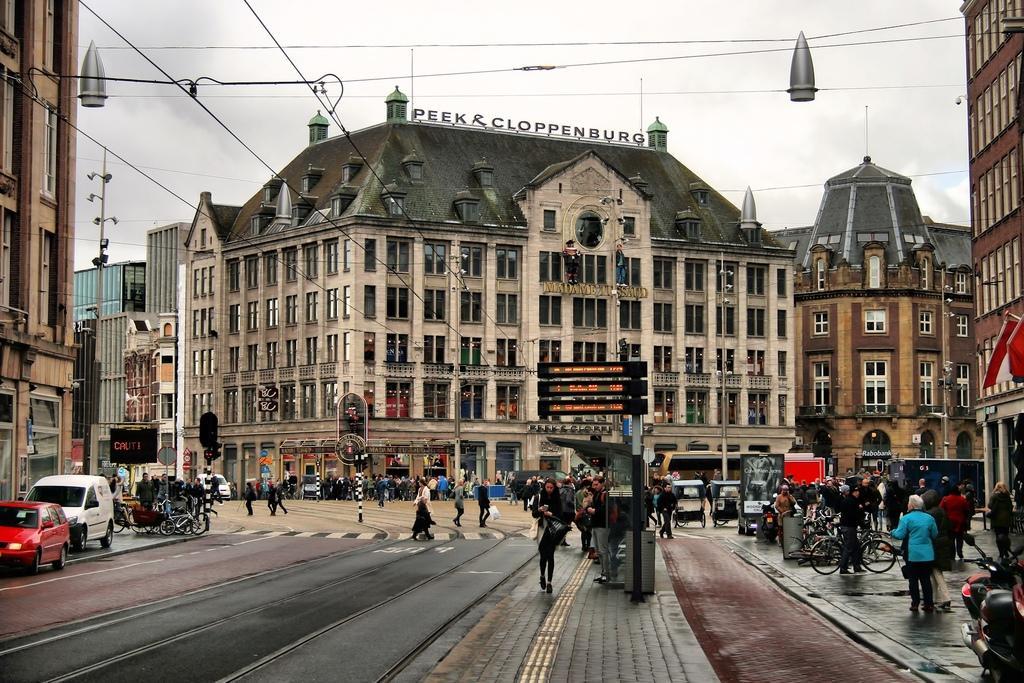Describe this image in one or two sentences. In the picture I can see buildings, vehicles, bicycles, people walking on the ground, wires, poles, street lights and some other objects on the ground. In the background I can see the sky. 